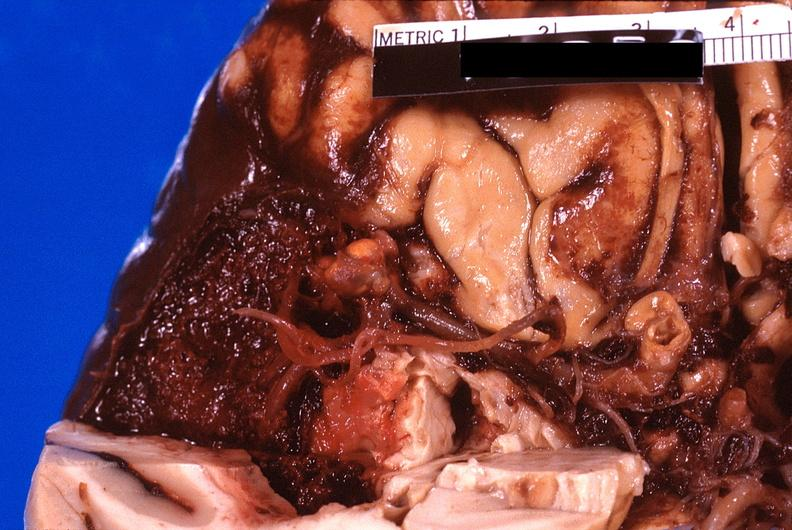does this image show brain, subarachanoid hemorrhage due to ruptured aneurysm?
Answer the question using a single word or phrase. Yes 